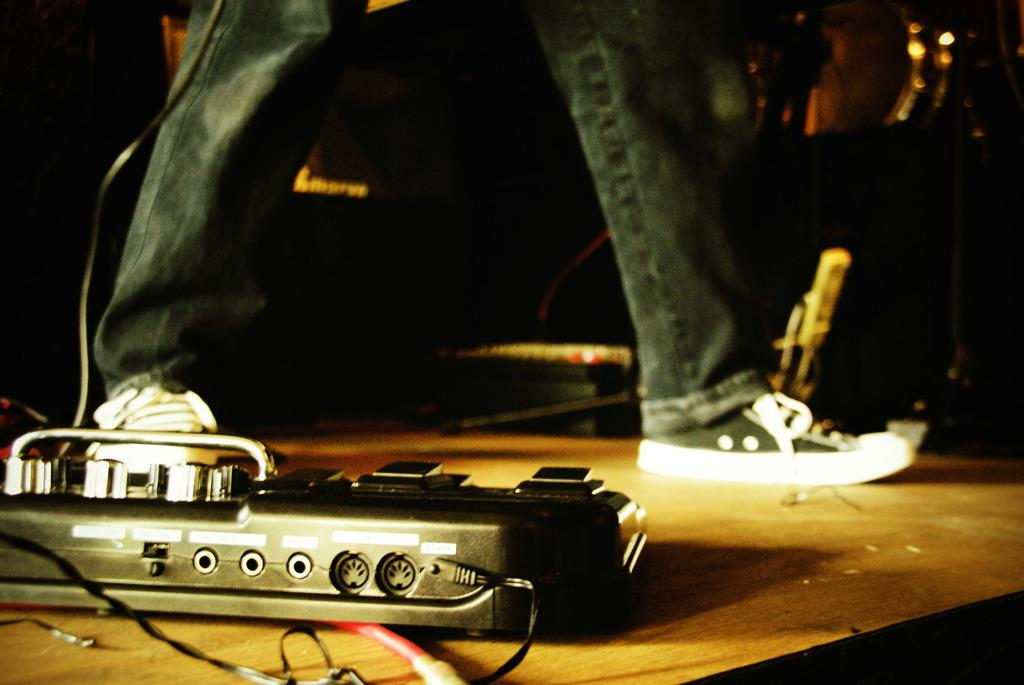What is the main object in the front of the image? There is an object in the front of the image, and it is black in color. Can you describe the person in the image? There is a person in the center of the image. What type of creature is flying in the air in the image? There is no creature flying in the air in the image. What type of scarecrow can be seen in the image? There is no scarecrow present in the image. 